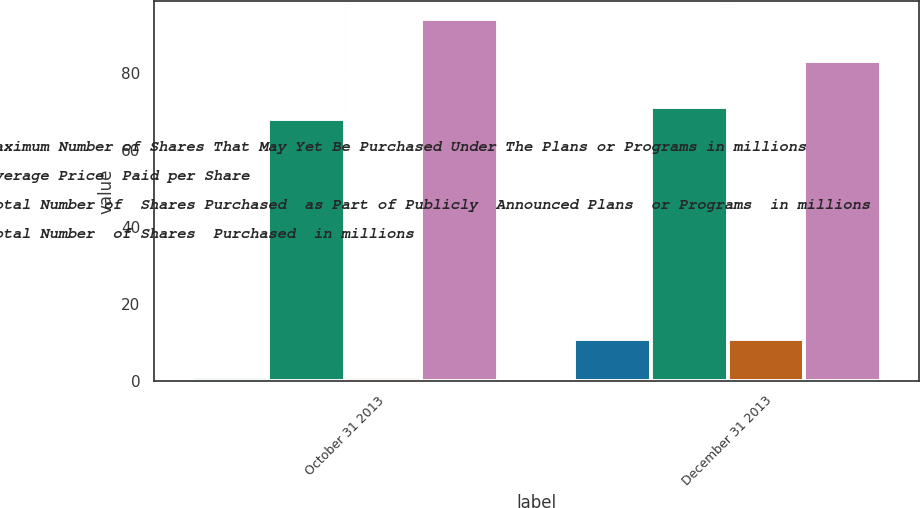Convert chart to OTSL. <chart><loc_0><loc_0><loc_500><loc_500><stacked_bar_chart><ecel><fcel>October 31 2013<fcel>December 31 2013<nl><fcel>Maximum Number of Shares That May Yet Be Purchased Under The Plans or Programs in millions<fcel>1<fcel>11<nl><fcel>Average Price  Paid per Share<fcel>68<fcel>71<nl><fcel>Total Number of  Shares Purchased  as Part of Publicly  Announced Plans  or Programs  in millions<fcel>1<fcel>11<nl><fcel>Total Number  of Shares  Purchased  in millions<fcel>94<fcel>83<nl></chart> 